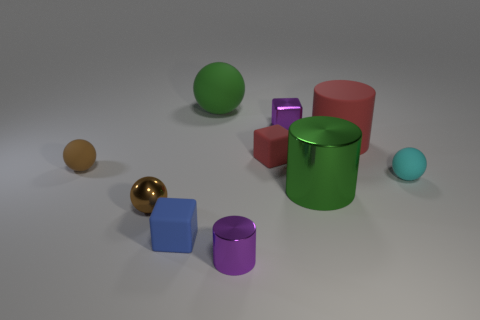Subtract all tiny brown metallic spheres. How many spheres are left? 3 Subtract 1 balls. How many balls are left? 3 Subtract all red balls. Subtract all gray cylinders. How many balls are left? 4 Subtract all cylinders. How many objects are left? 7 Subtract 0 yellow cubes. How many objects are left? 10 Subtract all tiny blue objects. Subtract all large green shiny cylinders. How many objects are left? 8 Add 2 rubber spheres. How many rubber spheres are left? 5 Add 2 cyan rubber balls. How many cyan rubber balls exist? 3 